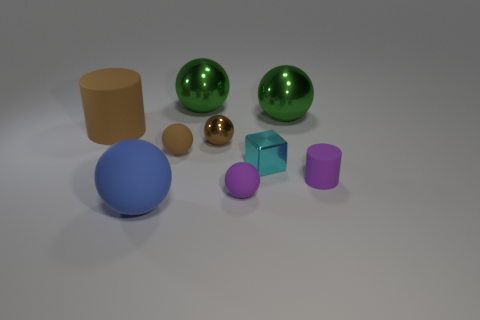How big is the sphere that is in front of the small metallic block and behind the large matte ball?
Your answer should be compact. Small. Is the number of small cyan blocks on the left side of the big blue thing greater than the number of large cylinders behind the large brown matte cylinder?
Offer a terse response. No. There is a rubber cylinder that is the same color as the small metal sphere; what is its size?
Ensure brevity in your answer.  Large. What is the color of the metal cube?
Ensure brevity in your answer.  Cyan. There is a rubber object that is both behind the cyan metallic block and on the right side of the large brown rubber thing; what is its color?
Keep it short and to the point. Brown. What is the color of the thing to the left of the large matte object in front of the tiny rubber sphere behind the small cyan block?
Offer a terse response. Brown. There is a metal sphere that is the same size as the purple rubber cylinder; what color is it?
Your response must be concise. Brown. The tiny purple object on the right side of the small shiny object that is in front of the tiny rubber object that is behind the purple matte cylinder is what shape?
Your answer should be very brief. Cylinder. What is the shape of the tiny matte object that is the same color as the small matte cylinder?
Offer a very short reply. Sphere. What number of things are purple cylinders or shiny spheres on the right side of the cyan shiny cube?
Your answer should be compact. 2. 